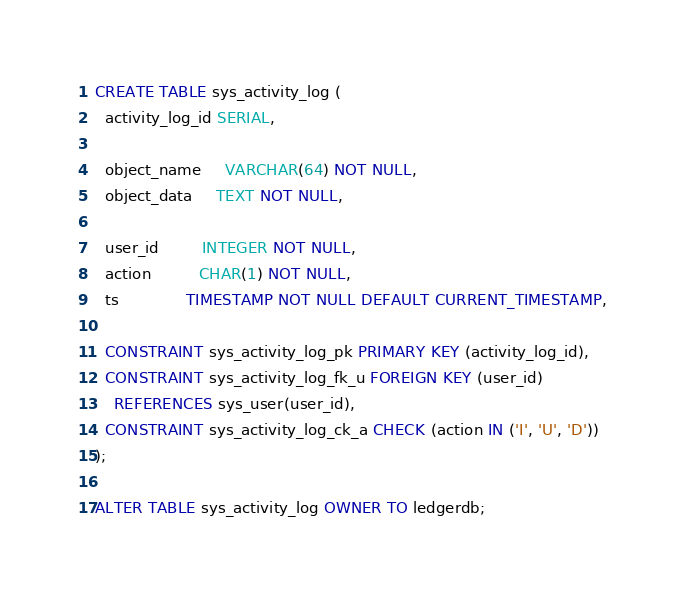Convert code to text. <code><loc_0><loc_0><loc_500><loc_500><_SQL_>CREATE TABLE sys_activity_log (
  activity_log_id SERIAL,

  object_name     VARCHAR(64) NOT NULL,
  object_data     TEXT NOT NULL,

  user_id         INTEGER NOT NULL,
  action          CHAR(1) NOT NULL,
  ts              TIMESTAMP NOT NULL DEFAULT CURRENT_TIMESTAMP,

  CONSTRAINT sys_activity_log_pk PRIMARY KEY (activity_log_id),
  CONSTRAINT sys_activity_log_fk_u FOREIGN KEY (user_id)
    REFERENCES sys_user(user_id),
  CONSTRAINT sys_activity_log_ck_a CHECK (action IN ('I', 'U', 'D'))
);

ALTER TABLE sys_activity_log OWNER TO ledgerdb;
</code> 